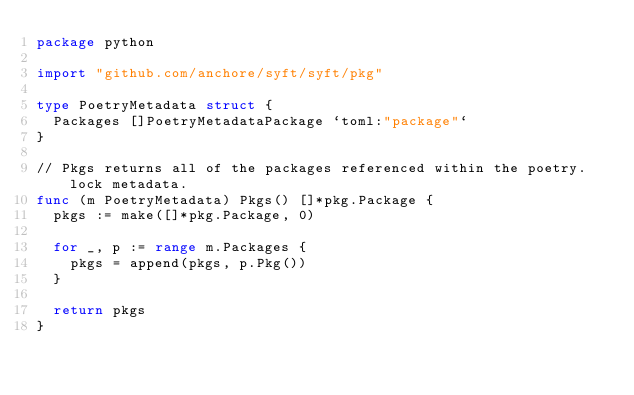<code> <loc_0><loc_0><loc_500><loc_500><_Go_>package python

import "github.com/anchore/syft/syft/pkg"

type PoetryMetadata struct {
	Packages []PoetryMetadataPackage `toml:"package"`
}

// Pkgs returns all of the packages referenced within the poetry.lock metadata.
func (m PoetryMetadata) Pkgs() []*pkg.Package {
	pkgs := make([]*pkg.Package, 0)

	for _, p := range m.Packages {
		pkgs = append(pkgs, p.Pkg())
	}

	return pkgs
}
</code> 